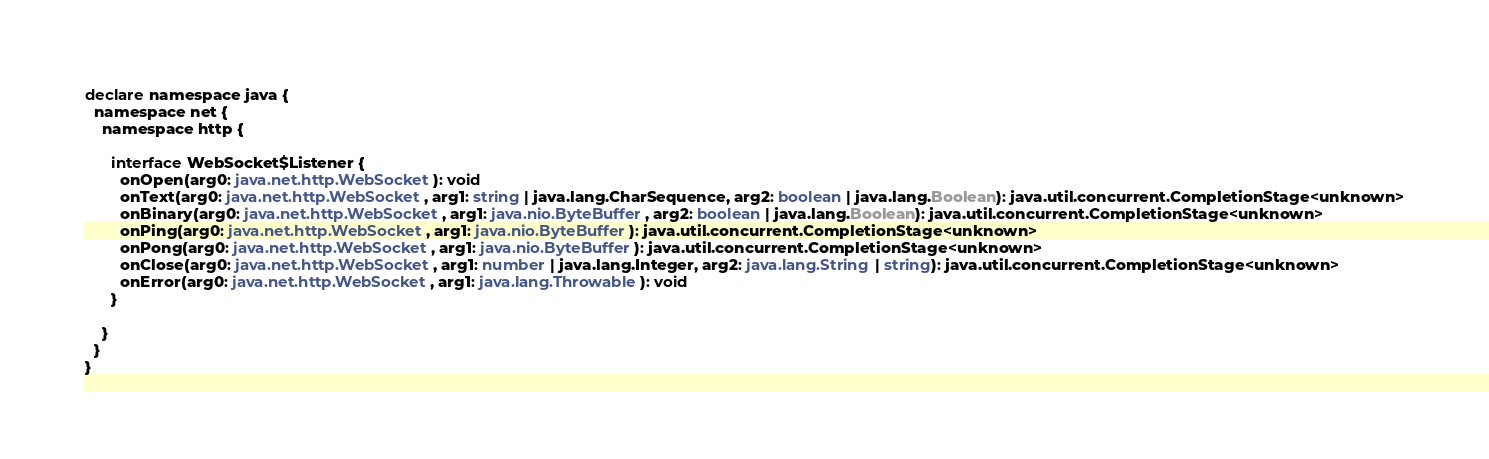Convert code to text. <code><loc_0><loc_0><loc_500><loc_500><_TypeScript_>declare namespace java {
  namespace net {
    namespace http {

      interface WebSocket$Listener {
        onOpen(arg0: java.net.http.WebSocket): void
        onText(arg0: java.net.http.WebSocket, arg1: string | java.lang.CharSequence, arg2: boolean | java.lang.Boolean): java.util.concurrent.CompletionStage<unknown>
        onBinary(arg0: java.net.http.WebSocket, arg1: java.nio.ByteBuffer, arg2: boolean | java.lang.Boolean): java.util.concurrent.CompletionStage<unknown>
        onPing(arg0: java.net.http.WebSocket, arg1: java.nio.ByteBuffer): java.util.concurrent.CompletionStage<unknown>
        onPong(arg0: java.net.http.WebSocket, arg1: java.nio.ByteBuffer): java.util.concurrent.CompletionStage<unknown>
        onClose(arg0: java.net.http.WebSocket, arg1: number | java.lang.Integer, arg2: java.lang.String | string): java.util.concurrent.CompletionStage<unknown>
        onError(arg0: java.net.http.WebSocket, arg1: java.lang.Throwable): void
      }

    }
  }
}
</code> 